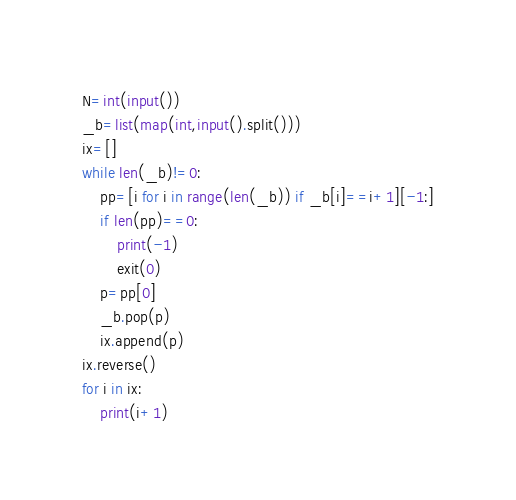Convert code to text. <code><loc_0><loc_0><loc_500><loc_500><_Python_>N=int(input())
_b=list(map(int,input().split()))
ix=[]
while len(_b)!=0:
    pp=[i for i in range(len(_b)) if _b[i]==i+1][-1:]
    if len(pp)==0:
        print(-1)
        exit(0)
    p=pp[0]
    _b.pop(p)
    ix.append(p)
ix.reverse()
for i in ix:
    print(i+1)
</code> 